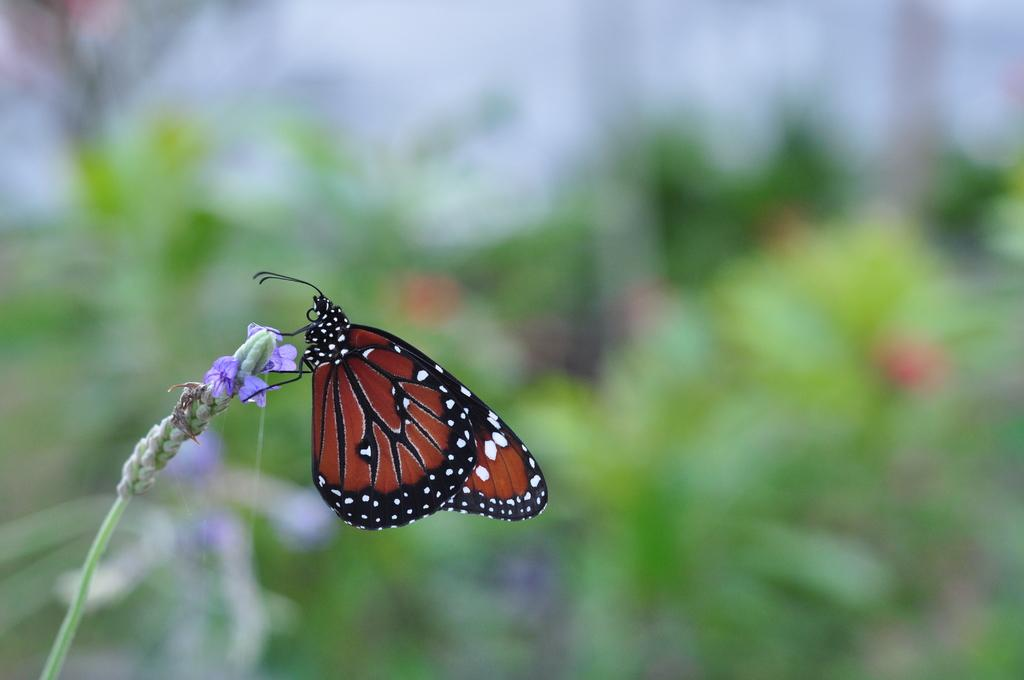What is the main subject of the image? There is a butterfly in the image. Where is the butterfly located? The butterfly is on a flower. Can you describe the background of the image? The background of the image is blurry. What type of support does the butterfly provide to the flower in the image? The butterfly does not provide support to the flower in the image; it is simply perched on it. 